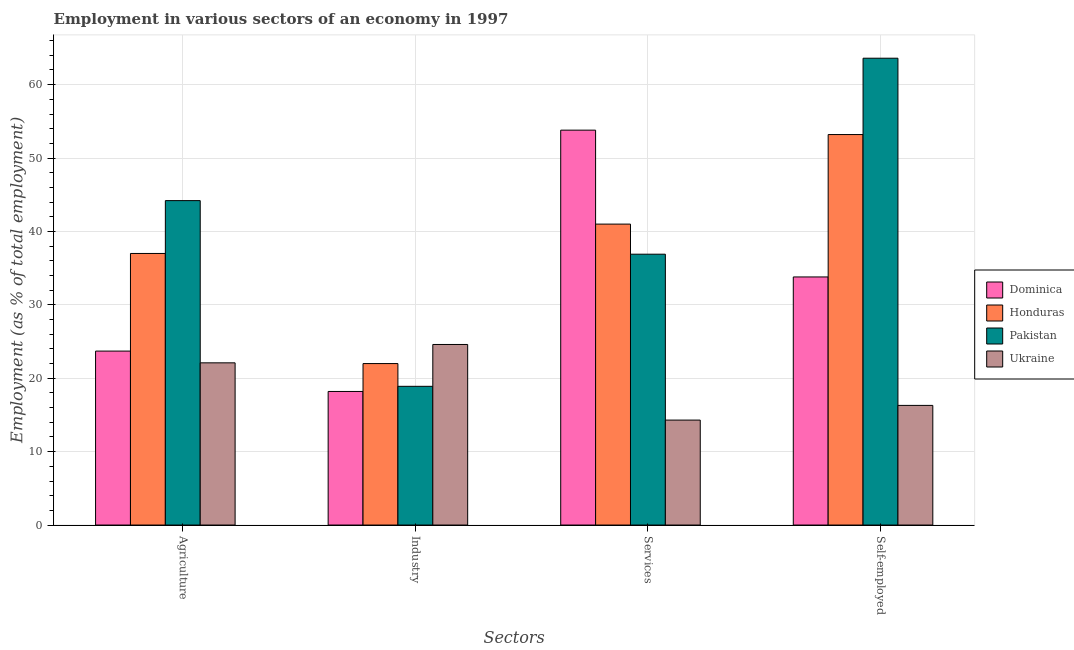How many different coloured bars are there?
Give a very brief answer. 4. Are the number of bars on each tick of the X-axis equal?
Give a very brief answer. Yes. How many bars are there on the 3rd tick from the right?
Your answer should be very brief. 4. What is the label of the 1st group of bars from the left?
Offer a terse response. Agriculture. Across all countries, what is the maximum percentage of workers in agriculture?
Your answer should be very brief. 44.2. Across all countries, what is the minimum percentage of workers in industry?
Ensure brevity in your answer.  18.2. In which country was the percentage of workers in industry minimum?
Make the answer very short. Dominica. What is the total percentage of self employed workers in the graph?
Offer a terse response. 166.9. What is the difference between the percentage of workers in agriculture in Ukraine and that in Honduras?
Offer a very short reply. -14.9. What is the difference between the percentage of workers in services in Dominica and the percentage of self employed workers in Ukraine?
Ensure brevity in your answer.  37.5. What is the average percentage of self employed workers per country?
Provide a succinct answer. 41.72. What is the difference between the percentage of workers in agriculture and percentage of self employed workers in Honduras?
Offer a very short reply. -16.2. What is the ratio of the percentage of workers in industry in Honduras to that in Ukraine?
Your answer should be compact. 0.89. Is the difference between the percentage of workers in services in Pakistan and Dominica greater than the difference between the percentage of workers in industry in Pakistan and Dominica?
Provide a short and direct response. No. What is the difference between the highest and the second highest percentage of self employed workers?
Offer a very short reply. 10.4. What is the difference between the highest and the lowest percentage of workers in industry?
Offer a very short reply. 6.4. In how many countries, is the percentage of workers in industry greater than the average percentage of workers in industry taken over all countries?
Provide a short and direct response. 2. Is the sum of the percentage of self employed workers in Dominica and Honduras greater than the maximum percentage of workers in industry across all countries?
Your answer should be very brief. Yes. What does the 4th bar from the left in Agriculture represents?
Ensure brevity in your answer.  Ukraine. What does the 1st bar from the right in Self-employed represents?
Ensure brevity in your answer.  Ukraine. Are all the bars in the graph horizontal?
Offer a very short reply. No. What is the difference between two consecutive major ticks on the Y-axis?
Your answer should be compact. 10. Does the graph contain grids?
Keep it short and to the point. Yes. Where does the legend appear in the graph?
Your answer should be compact. Center right. How many legend labels are there?
Your response must be concise. 4. How are the legend labels stacked?
Ensure brevity in your answer.  Vertical. What is the title of the graph?
Offer a terse response. Employment in various sectors of an economy in 1997. What is the label or title of the X-axis?
Your response must be concise. Sectors. What is the label or title of the Y-axis?
Provide a short and direct response. Employment (as % of total employment). What is the Employment (as % of total employment) in Dominica in Agriculture?
Offer a very short reply. 23.7. What is the Employment (as % of total employment) of Pakistan in Agriculture?
Keep it short and to the point. 44.2. What is the Employment (as % of total employment) in Ukraine in Agriculture?
Your answer should be very brief. 22.1. What is the Employment (as % of total employment) in Dominica in Industry?
Provide a short and direct response. 18.2. What is the Employment (as % of total employment) in Honduras in Industry?
Your answer should be compact. 22. What is the Employment (as % of total employment) in Pakistan in Industry?
Offer a terse response. 18.9. What is the Employment (as % of total employment) in Ukraine in Industry?
Ensure brevity in your answer.  24.6. What is the Employment (as % of total employment) in Dominica in Services?
Provide a short and direct response. 53.8. What is the Employment (as % of total employment) in Pakistan in Services?
Provide a succinct answer. 36.9. What is the Employment (as % of total employment) in Ukraine in Services?
Your answer should be compact. 14.3. What is the Employment (as % of total employment) in Dominica in Self-employed?
Provide a short and direct response. 33.8. What is the Employment (as % of total employment) of Honduras in Self-employed?
Provide a succinct answer. 53.2. What is the Employment (as % of total employment) in Pakistan in Self-employed?
Ensure brevity in your answer.  63.6. What is the Employment (as % of total employment) in Ukraine in Self-employed?
Your answer should be very brief. 16.3. Across all Sectors, what is the maximum Employment (as % of total employment) of Dominica?
Make the answer very short. 53.8. Across all Sectors, what is the maximum Employment (as % of total employment) of Honduras?
Give a very brief answer. 53.2. Across all Sectors, what is the maximum Employment (as % of total employment) in Pakistan?
Your answer should be very brief. 63.6. Across all Sectors, what is the maximum Employment (as % of total employment) of Ukraine?
Your answer should be very brief. 24.6. Across all Sectors, what is the minimum Employment (as % of total employment) in Dominica?
Your answer should be very brief. 18.2. Across all Sectors, what is the minimum Employment (as % of total employment) in Pakistan?
Keep it short and to the point. 18.9. Across all Sectors, what is the minimum Employment (as % of total employment) in Ukraine?
Offer a terse response. 14.3. What is the total Employment (as % of total employment) of Dominica in the graph?
Give a very brief answer. 129.5. What is the total Employment (as % of total employment) in Honduras in the graph?
Your answer should be compact. 153.2. What is the total Employment (as % of total employment) in Pakistan in the graph?
Ensure brevity in your answer.  163.6. What is the total Employment (as % of total employment) in Ukraine in the graph?
Give a very brief answer. 77.3. What is the difference between the Employment (as % of total employment) in Dominica in Agriculture and that in Industry?
Make the answer very short. 5.5. What is the difference between the Employment (as % of total employment) in Pakistan in Agriculture and that in Industry?
Provide a short and direct response. 25.3. What is the difference between the Employment (as % of total employment) of Dominica in Agriculture and that in Services?
Offer a terse response. -30.1. What is the difference between the Employment (as % of total employment) of Pakistan in Agriculture and that in Services?
Ensure brevity in your answer.  7.3. What is the difference between the Employment (as % of total employment) of Honduras in Agriculture and that in Self-employed?
Your answer should be compact. -16.2. What is the difference between the Employment (as % of total employment) of Pakistan in Agriculture and that in Self-employed?
Keep it short and to the point. -19.4. What is the difference between the Employment (as % of total employment) of Dominica in Industry and that in Services?
Your answer should be very brief. -35.6. What is the difference between the Employment (as % of total employment) of Dominica in Industry and that in Self-employed?
Your answer should be compact. -15.6. What is the difference between the Employment (as % of total employment) of Honduras in Industry and that in Self-employed?
Your answer should be compact. -31.2. What is the difference between the Employment (as % of total employment) of Pakistan in Industry and that in Self-employed?
Your answer should be compact. -44.7. What is the difference between the Employment (as % of total employment) of Ukraine in Industry and that in Self-employed?
Keep it short and to the point. 8.3. What is the difference between the Employment (as % of total employment) of Honduras in Services and that in Self-employed?
Make the answer very short. -12.2. What is the difference between the Employment (as % of total employment) in Pakistan in Services and that in Self-employed?
Give a very brief answer. -26.7. What is the difference between the Employment (as % of total employment) of Dominica in Agriculture and the Employment (as % of total employment) of Pakistan in Industry?
Offer a terse response. 4.8. What is the difference between the Employment (as % of total employment) of Dominica in Agriculture and the Employment (as % of total employment) of Ukraine in Industry?
Give a very brief answer. -0.9. What is the difference between the Employment (as % of total employment) of Pakistan in Agriculture and the Employment (as % of total employment) of Ukraine in Industry?
Your answer should be compact. 19.6. What is the difference between the Employment (as % of total employment) in Dominica in Agriculture and the Employment (as % of total employment) in Honduras in Services?
Keep it short and to the point. -17.3. What is the difference between the Employment (as % of total employment) in Dominica in Agriculture and the Employment (as % of total employment) in Ukraine in Services?
Your response must be concise. 9.4. What is the difference between the Employment (as % of total employment) in Honduras in Agriculture and the Employment (as % of total employment) in Pakistan in Services?
Make the answer very short. 0.1. What is the difference between the Employment (as % of total employment) of Honduras in Agriculture and the Employment (as % of total employment) of Ukraine in Services?
Offer a terse response. 22.7. What is the difference between the Employment (as % of total employment) of Pakistan in Agriculture and the Employment (as % of total employment) of Ukraine in Services?
Keep it short and to the point. 29.9. What is the difference between the Employment (as % of total employment) of Dominica in Agriculture and the Employment (as % of total employment) of Honduras in Self-employed?
Make the answer very short. -29.5. What is the difference between the Employment (as % of total employment) of Dominica in Agriculture and the Employment (as % of total employment) of Pakistan in Self-employed?
Provide a succinct answer. -39.9. What is the difference between the Employment (as % of total employment) in Honduras in Agriculture and the Employment (as % of total employment) in Pakistan in Self-employed?
Offer a very short reply. -26.6. What is the difference between the Employment (as % of total employment) in Honduras in Agriculture and the Employment (as % of total employment) in Ukraine in Self-employed?
Provide a short and direct response. 20.7. What is the difference between the Employment (as % of total employment) of Pakistan in Agriculture and the Employment (as % of total employment) of Ukraine in Self-employed?
Your answer should be compact. 27.9. What is the difference between the Employment (as % of total employment) of Dominica in Industry and the Employment (as % of total employment) of Honduras in Services?
Your answer should be very brief. -22.8. What is the difference between the Employment (as % of total employment) of Dominica in Industry and the Employment (as % of total employment) of Pakistan in Services?
Ensure brevity in your answer.  -18.7. What is the difference between the Employment (as % of total employment) of Honduras in Industry and the Employment (as % of total employment) of Pakistan in Services?
Offer a very short reply. -14.9. What is the difference between the Employment (as % of total employment) in Honduras in Industry and the Employment (as % of total employment) in Ukraine in Services?
Your answer should be compact. 7.7. What is the difference between the Employment (as % of total employment) of Pakistan in Industry and the Employment (as % of total employment) of Ukraine in Services?
Offer a very short reply. 4.6. What is the difference between the Employment (as % of total employment) of Dominica in Industry and the Employment (as % of total employment) of Honduras in Self-employed?
Provide a short and direct response. -35. What is the difference between the Employment (as % of total employment) in Dominica in Industry and the Employment (as % of total employment) in Pakistan in Self-employed?
Ensure brevity in your answer.  -45.4. What is the difference between the Employment (as % of total employment) of Dominica in Industry and the Employment (as % of total employment) of Ukraine in Self-employed?
Make the answer very short. 1.9. What is the difference between the Employment (as % of total employment) in Honduras in Industry and the Employment (as % of total employment) in Pakistan in Self-employed?
Provide a succinct answer. -41.6. What is the difference between the Employment (as % of total employment) of Dominica in Services and the Employment (as % of total employment) of Ukraine in Self-employed?
Provide a succinct answer. 37.5. What is the difference between the Employment (as % of total employment) in Honduras in Services and the Employment (as % of total employment) in Pakistan in Self-employed?
Keep it short and to the point. -22.6. What is the difference between the Employment (as % of total employment) in Honduras in Services and the Employment (as % of total employment) in Ukraine in Self-employed?
Provide a short and direct response. 24.7. What is the difference between the Employment (as % of total employment) in Pakistan in Services and the Employment (as % of total employment) in Ukraine in Self-employed?
Keep it short and to the point. 20.6. What is the average Employment (as % of total employment) in Dominica per Sectors?
Give a very brief answer. 32.38. What is the average Employment (as % of total employment) in Honduras per Sectors?
Give a very brief answer. 38.3. What is the average Employment (as % of total employment) in Pakistan per Sectors?
Make the answer very short. 40.9. What is the average Employment (as % of total employment) in Ukraine per Sectors?
Ensure brevity in your answer.  19.32. What is the difference between the Employment (as % of total employment) in Dominica and Employment (as % of total employment) in Pakistan in Agriculture?
Keep it short and to the point. -20.5. What is the difference between the Employment (as % of total employment) in Dominica and Employment (as % of total employment) in Ukraine in Agriculture?
Offer a terse response. 1.6. What is the difference between the Employment (as % of total employment) in Honduras and Employment (as % of total employment) in Pakistan in Agriculture?
Offer a very short reply. -7.2. What is the difference between the Employment (as % of total employment) in Honduras and Employment (as % of total employment) in Ukraine in Agriculture?
Offer a terse response. 14.9. What is the difference between the Employment (as % of total employment) in Pakistan and Employment (as % of total employment) in Ukraine in Agriculture?
Make the answer very short. 22.1. What is the difference between the Employment (as % of total employment) in Dominica and Employment (as % of total employment) in Ukraine in Services?
Offer a terse response. 39.5. What is the difference between the Employment (as % of total employment) of Honduras and Employment (as % of total employment) of Pakistan in Services?
Give a very brief answer. 4.1. What is the difference between the Employment (as % of total employment) in Honduras and Employment (as % of total employment) in Ukraine in Services?
Provide a succinct answer. 26.7. What is the difference between the Employment (as % of total employment) in Pakistan and Employment (as % of total employment) in Ukraine in Services?
Give a very brief answer. 22.6. What is the difference between the Employment (as % of total employment) in Dominica and Employment (as % of total employment) in Honduras in Self-employed?
Offer a very short reply. -19.4. What is the difference between the Employment (as % of total employment) of Dominica and Employment (as % of total employment) of Pakistan in Self-employed?
Your response must be concise. -29.8. What is the difference between the Employment (as % of total employment) of Honduras and Employment (as % of total employment) of Ukraine in Self-employed?
Ensure brevity in your answer.  36.9. What is the difference between the Employment (as % of total employment) in Pakistan and Employment (as % of total employment) in Ukraine in Self-employed?
Your response must be concise. 47.3. What is the ratio of the Employment (as % of total employment) in Dominica in Agriculture to that in Industry?
Offer a terse response. 1.3. What is the ratio of the Employment (as % of total employment) in Honduras in Agriculture to that in Industry?
Your answer should be compact. 1.68. What is the ratio of the Employment (as % of total employment) of Pakistan in Agriculture to that in Industry?
Offer a terse response. 2.34. What is the ratio of the Employment (as % of total employment) in Ukraine in Agriculture to that in Industry?
Your response must be concise. 0.9. What is the ratio of the Employment (as % of total employment) of Dominica in Agriculture to that in Services?
Your answer should be compact. 0.44. What is the ratio of the Employment (as % of total employment) in Honduras in Agriculture to that in Services?
Give a very brief answer. 0.9. What is the ratio of the Employment (as % of total employment) of Pakistan in Agriculture to that in Services?
Provide a succinct answer. 1.2. What is the ratio of the Employment (as % of total employment) in Ukraine in Agriculture to that in Services?
Your answer should be very brief. 1.55. What is the ratio of the Employment (as % of total employment) of Dominica in Agriculture to that in Self-employed?
Provide a short and direct response. 0.7. What is the ratio of the Employment (as % of total employment) in Honduras in Agriculture to that in Self-employed?
Give a very brief answer. 0.7. What is the ratio of the Employment (as % of total employment) of Pakistan in Agriculture to that in Self-employed?
Provide a succinct answer. 0.69. What is the ratio of the Employment (as % of total employment) in Ukraine in Agriculture to that in Self-employed?
Ensure brevity in your answer.  1.36. What is the ratio of the Employment (as % of total employment) of Dominica in Industry to that in Services?
Give a very brief answer. 0.34. What is the ratio of the Employment (as % of total employment) in Honduras in Industry to that in Services?
Offer a terse response. 0.54. What is the ratio of the Employment (as % of total employment) of Pakistan in Industry to that in Services?
Your response must be concise. 0.51. What is the ratio of the Employment (as % of total employment) of Ukraine in Industry to that in Services?
Your answer should be very brief. 1.72. What is the ratio of the Employment (as % of total employment) of Dominica in Industry to that in Self-employed?
Make the answer very short. 0.54. What is the ratio of the Employment (as % of total employment) in Honduras in Industry to that in Self-employed?
Your answer should be compact. 0.41. What is the ratio of the Employment (as % of total employment) of Pakistan in Industry to that in Self-employed?
Keep it short and to the point. 0.3. What is the ratio of the Employment (as % of total employment) in Ukraine in Industry to that in Self-employed?
Make the answer very short. 1.51. What is the ratio of the Employment (as % of total employment) in Dominica in Services to that in Self-employed?
Provide a succinct answer. 1.59. What is the ratio of the Employment (as % of total employment) in Honduras in Services to that in Self-employed?
Provide a succinct answer. 0.77. What is the ratio of the Employment (as % of total employment) of Pakistan in Services to that in Self-employed?
Your response must be concise. 0.58. What is the ratio of the Employment (as % of total employment) in Ukraine in Services to that in Self-employed?
Provide a short and direct response. 0.88. What is the difference between the highest and the second highest Employment (as % of total employment) in Dominica?
Provide a succinct answer. 20. What is the difference between the highest and the second highest Employment (as % of total employment) of Honduras?
Keep it short and to the point. 12.2. What is the difference between the highest and the second highest Employment (as % of total employment) in Ukraine?
Offer a very short reply. 2.5. What is the difference between the highest and the lowest Employment (as % of total employment) of Dominica?
Your answer should be compact. 35.6. What is the difference between the highest and the lowest Employment (as % of total employment) in Honduras?
Make the answer very short. 31.2. What is the difference between the highest and the lowest Employment (as % of total employment) in Pakistan?
Ensure brevity in your answer.  44.7. 